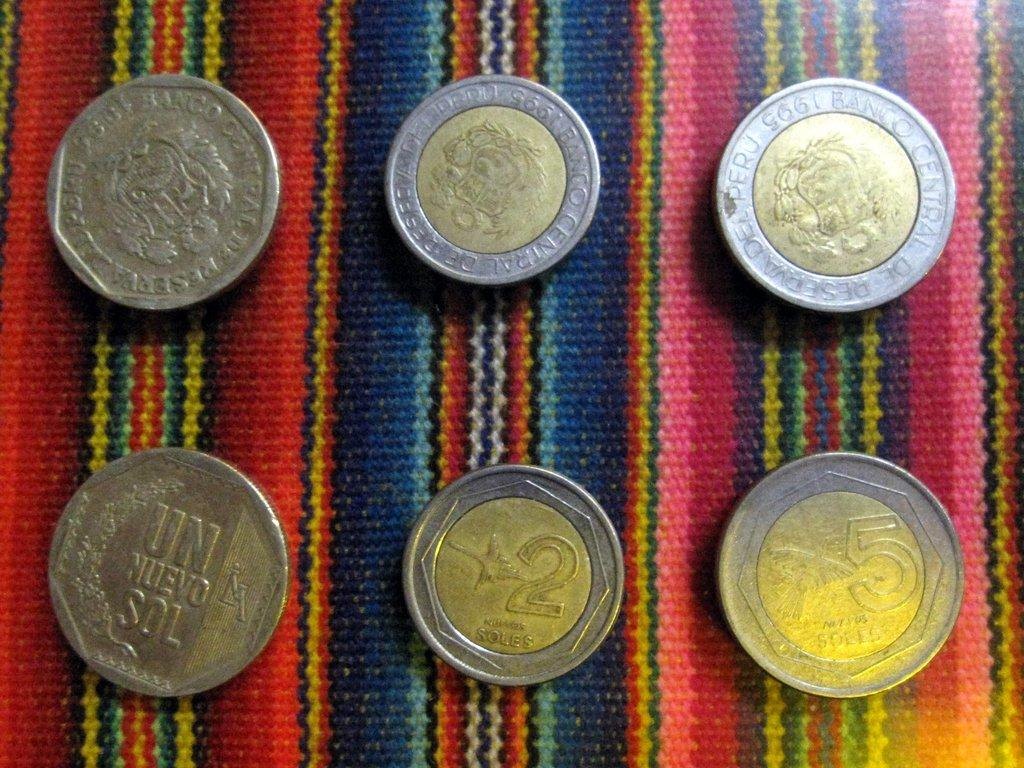<image>
Provide a brief description of the given image. a coin that has the number 2 on the face 